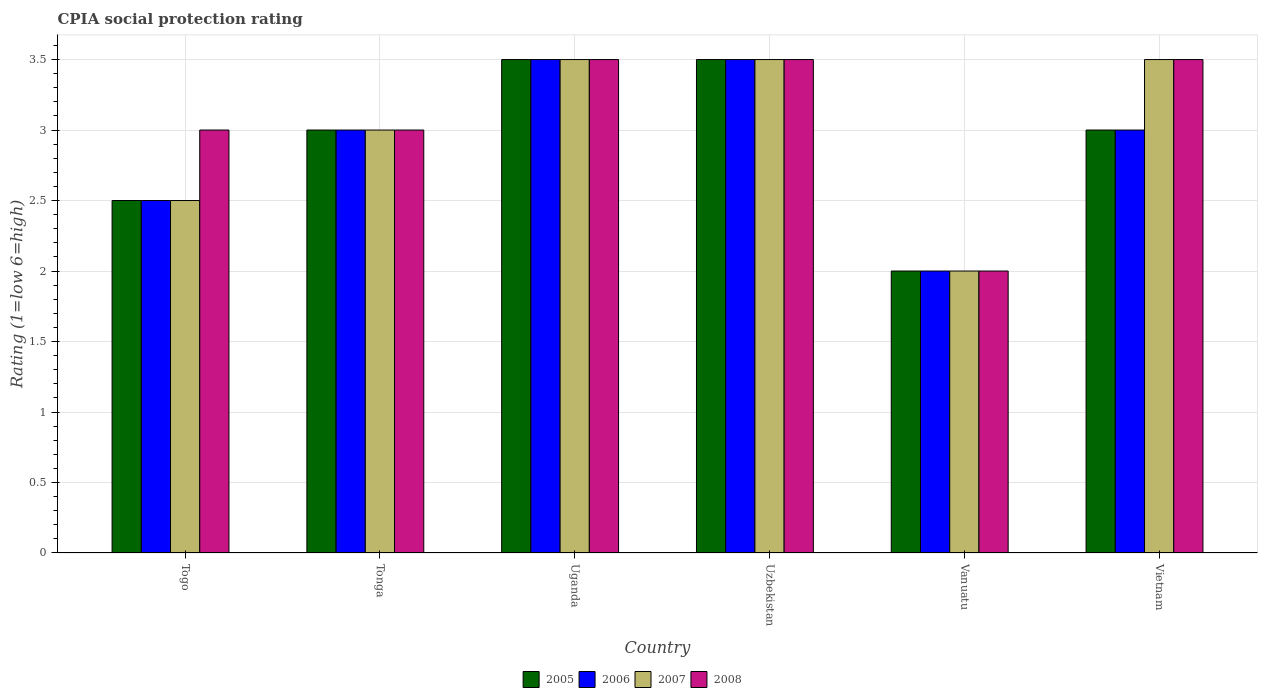How many different coloured bars are there?
Offer a terse response. 4. How many groups of bars are there?
Offer a terse response. 6. Are the number of bars on each tick of the X-axis equal?
Provide a succinct answer. Yes. How many bars are there on the 3rd tick from the left?
Make the answer very short. 4. What is the label of the 6th group of bars from the left?
Offer a terse response. Vietnam. In how many cases, is the number of bars for a given country not equal to the number of legend labels?
Give a very brief answer. 0. What is the CPIA rating in 2008 in Tonga?
Ensure brevity in your answer.  3. In which country was the CPIA rating in 2008 maximum?
Your answer should be compact. Uganda. In which country was the CPIA rating in 2006 minimum?
Provide a succinct answer. Vanuatu. What is the difference between the CPIA rating in 2008 in Togo and that in Vietnam?
Ensure brevity in your answer.  -0.5. What is the average CPIA rating in 2008 per country?
Your answer should be very brief. 3.08. What is the difference between the CPIA rating of/in 2005 and CPIA rating of/in 2008 in Togo?
Your response must be concise. -0.5. What is the ratio of the CPIA rating in 2007 in Tonga to that in Vietnam?
Give a very brief answer. 0.86. Is the CPIA rating in 2008 in Togo less than that in Uzbekistan?
Provide a succinct answer. Yes. What does the 2nd bar from the right in Vietnam represents?
Provide a succinct answer. 2007. Is it the case that in every country, the sum of the CPIA rating in 2005 and CPIA rating in 2006 is greater than the CPIA rating in 2008?
Your response must be concise. Yes. How many bars are there?
Ensure brevity in your answer.  24. What is the difference between two consecutive major ticks on the Y-axis?
Keep it short and to the point. 0.5. Does the graph contain any zero values?
Offer a very short reply. No. Does the graph contain grids?
Offer a terse response. Yes. Where does the legend appear in the graph?
Provide a succinct answer. Bottom center. What is the title of the graph?
Ensure brevity in your answer.  CPIA social protection rating. What is the Rating (1=low 6=high) in 2006 in Togo?
Your answer should be very brief. 2.5. What is the Rating (1=low 6=high) of 2008 in Togo?
Offer a very short reply. 3. What is the Rating (1=low 6=high) of 2006 in Tonga?
Provide a succinct answer. 3. What is the Rating (1=low 6=high) in 2007 in Tonga?
Offer a very short reply. 3. What is the Rating (1=low 6=high) of 2008 in Tonga?
Your answer should be very brief. 3. What is the Rating (1=low 6=high) in 2005 in Uganda?
Your response must be concise. 3.5. What is the Rating (1=low 6=high) of 2006 in Uganda?
Give a very brief answer. 3.5. What is the Rating (1=low 6=high) of 2007 in Uganda?
Offer a very short reply. 3.5. What is the Rating (1=low 6=high) in 2007 in Uzbekistan?
Your response must be concise. 3.5. What is the Rating (1=low 6=high) in 2008 in Uzbekistan?
Offer a terse response. 3.5. What is the Rating (1=low 6=high) in 2005 in Vanuatu?
Make the answer very short. 2. What is the Rating (1=low 6=high) in 2007 in Vanuatu?
Your answer should be very brief. 2. What is the Rating (1=low 6=high) in 2008 in Vanuatu?
Offer a terse response. 2. What is the Rating (1=low 6=high) in 2006 in Vietnam?
Offer a terse response. 3. Across all countries, what is the maximum Rating (1=low 6=high) in 2005?
Your response must be concise. 3.5. Across all countries, what is the minimum Rating (1=low 6=high) of 2005?
Make the answer very short. 2. Across all countries, what is the minimum Rating (1=low 6=high) of 2006?
Offer a very short reply. 2. Across all countries, what is the minimum Rating (1=low 6=high) of 2007?
Keep it short and to the point. 2. What is the difference between the Rating (1=low 6=high) of 2005 in Togo and that in Tonga?
Provide a short and direct response. -0.5. What is the difference between the Rating (1=low 6=high) in 2006 in Togo and that in Tonga?
Make the answer very short. -0.5. What is the difference between the Rating (1=low 6=high) of 2007 in Togo and that in Tonga?
Offer a terse response. -0.5. What is the difference between the Rating (1=low 6=high) in 2006 in Togo and that in Uganda?
Your answer should be compact. -1. What is the difference between the Rating (1=low 6=high) in 2007 in Togo and that in Uganda?
Your response must be concise. -1. What is the difference between the Rating (1=low 6=high) of 2008 in Togo and that in Uganda?
Your response must be concise. -0.5. What is the difference between the Rating (1=low 6=high) in 2005 in Togo and that in Uzbekistan?
Provide a succinct answer. -1. What is the difference between the Rating (1=low 6=high) of 2006 in Togo and that in Uzbekistan?
Offer a terse response. -1. What is the difference between the Rating (1=low 6=high) of 2007 in Togo and that in Uzbekistan?
Offer a very short reply. -1. What is the difference between the Rating (1=low 6=high) in 2005 in Togo and that in Vanuatu?
Offer a terse response. 0.5. What is the difference between the Rating (1=low 6=high) in 2007 in Togo and that in Vanuatu?
Your response must be concise. 0.5. What is the difference between the Rating (1=low 6=high) of 2006 in Togo and that in Vietnam?
Give a very brief answer. -0.5. What is the difference between the Rating (1=low 6=high) of 2007 in Togo and that in Vietnam?
Offer a terse response. -1. What is the difference between the Rating (1=low 6=high) in 2006 in Tonga and that in Uganda?
Offer a very short reply. -0.5. What is the difference between the Rating (1=low 6=high) of 2007 in Tonga and that in Uganda?
Give a very brief answer. -0.5. What is the difference between the Rating (1=low 6=high) of 2005 in Tonga and that in Uzbekistan?
Your answer should be compact. -0.5. What is the difference between the Rating (1=low 6=high) of 2008 in Tonga and that in Uzbekistan?
Keep it short and to the point. -0.5. What is the difference between the Rating (1=low 6=high) of 2008 in Tonga and that in Vanuatu?
Keep it short and to the point. 1. What is the difference between the Rating (1=low 6=high) in 2005 in Tonga and that in Vietnam?
Offer a terse response. 0. What is the difference between the Rating (1=low 6=high) in 2006 in Tonga and that in Vietnam?
Keep it short and to the point. 0. What is the difference between the Rating (1=low 6=high) of 2007 in Uganda and that in Uzbekistan?
Provide a short and direct response. 0. What is the difference between the Rating (1=low 6=high) of 2008 in Uganda and that in Uzbekistan?
Your answer should be very brief. 0. What is the difference between the Rating (1=low 6=high) in 2005 in Uganda and that in Vanuatu?
Ensure brevity in your answer.  1.5. What is the difference between the Rating (1=low 6=high) in 2007 in Uganda and that in Vanuatu?
Provide a succinct answer. 1.5. What is the difference between the Rating (1=low 6=high) in 2008 in Uganda and that in Vanuatu?
Your response must be concise. 1.5. What is the difference between the Rating (1=low 6=high) of 2005 in Uganda and that in Vietnam?
Ensure brevity in your answer.  0.5. What is the difference between the Rating (1=low 6=high) of 2007 in Uganda and that in Vietnam?
Ensure brevity in your answer.  0. What is the difference between the Rating (1=low 6=high) in 2008 in Uganda and that in Vietnam?
Keep it short and to the point. 0. What is the difference between the Rating (1=low 6=high) in 2006 in Uzbekistan and that in Vanuatu?
Make the answer very short. 1.5. What is the difference between the Rating (1=low 6=high) of 2007 in Uzbekistan and that in Vanuatu?
Provide a succinct answer. 1.5. What is the difference between the Rating (1=low 6=high) in 2008 in Vanuatu and that in Vietnam?
Keep it short and to the point. -1.5. What is the difference between the Rating (1=low 6=high) of 2005 in Togo and the Rating (1=low 6=high) of 2006 in Tonga?
Your answer should be very brief. -0.5. What is the difference between the Rating (1=low 6=high) of 2005 in Togo and the Rating (1=low 6=high) of 2008 in Tonga?
Keep it short and to the point. -0.5. What is the difference between the Rating (1=low 6=high) in 2007 in Togo and the Rating (1=low 6=high) in 2008 in Tonga?
Offer a terse response. -0.5. What is the difference between the Rating (1=low 6=high) in 2005 in Togo and the Rating (1=low 6=high) in 2007 in Uganda?
Your response must be concise. -1. What is the difference between the Rating (1=low 6=high) of 2005 in Togo and the Rating (1=low 6=high) of 2008 in Uganda?
Make the answer very short. -1. What is the difference between the Rating (1=low 6=high) in 2006 in Togo and the Rating (1=low 6=high) in 2007 in Uganda?
Make the answer very short. -1. What is the difference between the Rating (1=low 6=high) in 2006 in Togo and the Rating (1=low 6=high) in 2008 in Uganda?
Your answer should be very brief. -1. What is the difference between the Rating (1=low 6=high) of 2007 in Togo and the Rating (1=low 6=high) of 2008 in Uganda?
Provide a short and direct response. -1. What is the difference between the Rating (1=low 6=high) of 2005 in Togo and the Rating (1=low 6=high) of 2007 in Uzbekistan?
Keep it short and to the point. -1. What is the difference between the Rating (1=low 6=high) of 2006 in Togo and the Rating (1=low 6=high) of 2007 in Uzbekistan?
Give a very brief answer. -1. What is the difference between the Rating (1=low 6=high) of 2006 in Togo and the Rating (1=low 6=high) of 2008 in Vanuatu?
Ensure brevity in your answer.  0.5. What is the difference between the Rating (1=low 6=high) of 2007 in Togo and the Rating (1=low 6=high) of 2008 in Vanuatu?
Keep it short and to the point. 0.5. What is the difference between the Rating (1=low 6=high) in 2005 in Togo and the Rating (1=low 6=high) in 2006 in Vietnam?
Offer a very short reply. -0.5. What is the difference between the Rating (1=low 6=high) in 2005 in Togo and the Rating (1=low 6=high) in 2007 in Vietnam?
Ensure brevity in your answer.  -1. What is the difference between the Rating (1=low 6=high) in 2005 in Togo and the Rating (1=low 6=high) in 2008 in Vietnam?
Make the answer very short. -1. What is the difference between the Rating (1=low 6=high) of 2006 in Togo and the Rating (1=low 6=high) of 2007 in Vietnam?
Give a very brief answer. -1. What is the difference between the Rating (1=low 6=high) in 2006 in Tonga and the Rating (1=low 6=high) in 2007 in Uganda?
Your response must be concise. -0.5. What is the difference between the Rating (1=low 6=high) of 2006 in Tonga and the Rating (1=low 6=high) of 2008 in Uganda?
Ensure brevity in your answer.  -0.5. What is the difference between the Rating (1=low 6=high) of 2007 in Tonga and the Rating (1=low 6=high) of 2008 in Uganda?
Ensure brevity in your answer.  -0.5. What is the difference between the Rating (1=low 6=high) in 2005 in Tonga and the Rating (1=low 6=high) in 2006 in Uzbekistan?
Your response must be concise. -0.5. What is the difference between the Rating (1=low 6=high) in 2005 in Tonga and the Rating (1=low 6=high) in 2007 in Uzbekistan?
Keep it short and to the point. -0.5. What is the difference between the Rating (1=low 6=high) of 2005 in Tonga and the Rating (1=low 6=high) of 2008 in Vanuatu?
Make the answer very short. 1. What is the difference between the Rating (1=low 6=high) of 2006 in Tonga and the Rating (1=low 6=high) of 2008 in Vanuatu?
Your answer should be very brief. 1. What is the difference between the Rating (1=low 6=high) in 2007 in Tonga and the Rating (1=low 6=high) in 2008 in Vanuatu?
Keep it short and to the point. 1. What is the difference between the Rating (1=low 6=high) in 2005 in Tonga and the Rating (1=low 6=high) in 2006 in Vietnam?
Provide a succinct answer. 0. What is the difference between the Rating (1=low 6=high) in 2005 in Tonga and the Rating (1=low 6=high) in 2007 in Vietnam?
Offer a terse response. -0.5. What is the difference between the Rating (1=low 6=high) of 2006 in Tonga and the Rating (1=low 6=high) of 2008 in Vietnam?
Make the answer very short. -0.5. What is the difference between the Rating (1=low 6=high) of 2005 in Uganda and the Rating (1=low 6=high) of 2006 in Uzbekistan?
Give a very brief answer. 0. What is the difference between the Rating (1=low 6=high) of 2006 in Uganda and the Rating (1=low 6=high) of 2007 in Uzbekistan?
Offer a terse response. 0. What is the difference between the Rating (1=low 6=high) in 2006 in Uganda and the Rating (1=low 6=high) in 2008 in Uzbekistan?
Ensure brevity in your answer.  0. What is the difference between the Rating (1=low 6=high) in 2005 in Uganda and the Rating (1=low 6=high) in 2006 in Vanuatu?
Your answer should be compact. 1.5. What is the difference between the Rating (1=low 6=high) of 2005 in Uganda and the Rating (1=low 6=high) of 2008 in Vanuatu?
Your response must be concise. 1.5. What is the difference between the Rating (1=low 6=high) of 2006 in Uganda and the Rating (1=low 6=high) of 2008 in Vanuatu?
Your answer should be very brief. 1.5. What is the difference between the Rating (1=low 6=high) of 2005 in Uganda and the Rating (1=low 6=high) of 2006 in Vietnam?
Your response must be concise. 0.5. What is the difference between the Rating (1=low 6=high) in 2005 in Uganda and the Rating (1=low 6=high) in 2007 in Vietnam?
Provide a short and direct response. 0. What is the difference between the Rating (1=low 6=high) in 2005 in Uganda and the Rating (1=low 6=high) in 2008 in Vietnam?
Provide a succinct answer. 0. What is the difference between the Rating (1=low 6=high) in 2006 in Uganda and the Rating (1=low 6=high) in 2007 in Vietnam?
Offer a very short reply. 0. What is the difference between the Rating (1=low 6=high) in 2006 in Uganda and the Rating (1=low 6=high) in 2008 in Vietnam?
Keep it short and to the point. 0. What is the difference between the Rating (1=low 6=high) of 2007 in Uganda and the Rating (1=low 6=high) of 2008 in Vietnam?
Provide a succinct answer. 0. What is the difference between the Rating (1=low 6=high) of 2005 in Uzbekistan and the Rating (1=low 6=high) of 2006 in Vanuatu?
Give a very brief answer. 1.5. What is the difference between the Rating (1=low 6=high) in 2006 in Uzbekistan and the Rating (1=low 6=high) in 2007 in Vanuatu?
Offer a terse response. 1.5. What is the difference between the Rating (1=low 6=high) of 2005 in Uzbekistan and the Rating (1=low 6=high) of 2006 in Vietnam?
Give a very brief answer. 0.5. What is the difference between the Rating (1=low 6=high) in 2006 in Uzbekistan and the Rating (1=low 6=high) in 2008 in Vietnam?
Your answer should be compact. 0. What is the difference between the Rating (1=low 6=high) of 2005 in Vanuatu and the Rating (1=low 6=high) of 2006 in Vietnam?
Give a very brief answer. -1. What is the average Rating (1=low 6=high) of 2005 per country?
Keep it short and to the point. 2.92. What is the average Rating (1=low 6=high) in 2006 per country?
Keep it short and to the point. 2.92. What is the average Rating (1=low 6=high) of 2008 per country?
Give a very brief answer. 3.08. What is the difference between the Rating (1=low 6=high) in 2005 and Rating (1=low 6=high) in 2006 in Togo?
Provide a short and direct response. 0. What is the difference between the Rating (1=low 6=high) of 2005 and Rating (1=low 6=high) of 2007 in Togo?
Keep it short and to the point. 0. What is the difference between the Rating (1=low 6=high) of 2006 and Rating (1=low 6=high) of 2007 in Togo?
Your answer should be very brief. 0. What is the difference between the Rating (1=low 6=high) in 2005 and Rating (1=low 6=high) in 2008 in Tonga?
Your response must be concise. 0. What is the difference between the Rating (1=low 6=high) of 2006 and Rating (1=low 6=high) of 2007 in Tonga?
Make the answer very short. 0. What is the difference between the Rating (1=low 6=high) in 2007 and Rating (1=low 6=high) in 2008 in Tonga?
Keep it short and to the point. 0. What is the difference between the Rating (1=low 6=high) in 2005 and Rating (1=low 6=high) in 2006 in Uganda?
Your answer should be very brief. 0. What is the difference between the Rating (1=low 6=high) in 2005 and Rating (1=low 6=high) in 2007 in Uganda?
Your answer should be very brief. 0. What is the difference between the Rating (1=low 6=high) in 2006 and Rating (1=low 6=high) in 2007 in Uganda?
Ensure brevity in your answer.  0. What is the difference between the Rating (1=low 6=high) in 2006 and Rating (1=low 6=high) in 2008 in Uganda?
Ensure brevity in your answer.  0. What is the difference between the Rating (1=low 6=high) in 2007 and Rating (1=low 6=high) in 2008 in Uganda?
Your answer should be compact. 0. What is the difference between the Rating (1=low 6=high) of 2005 and Rating (1=low 6=high) of 2006 in Uzbekistan?
Your response must be concise. 0. What is the difference between the Rating (1=low 6=high) in 2005 and Rating (1=low 6=high) in 2008 in Uzbekistan?
Ensure brevity in your answer.  0. What is the difference between the Rating (1=low 6=high) in 2006 and Rating (1=low 6=high) in 2007 in Uzbekistan?
Ensure brevity in your answer.  0. What is the difference between the Rating (1=low 6=high) of 2006 and Rating (1=low 6=high) of 2008 in Uzbekistan?
Keep it short and to the point. 0. What is the difference between the Rating (1=low 6=high) in 2007 and Rating (1=low 6=high) in 2008 in Uzbekistan?
Your response must be concise. 0. What is the difference between the Rating (1=low 6=high) in 2005 and Rating (1=low 6=high) in 2006 in Vanuatu?
Your answer should be compact. 0. What is the difference between the Rating (1=low 6=high) in 2005 and Rating (1=low 6=high) in 2008 in Vanuatu?
Your answer should be compact. 0. What is the difference between the Rating (1=low 6=high) of 2006 and Rating (1=low 6=high) of 2007 in Vanuatu?
Give a very brief answer. 0. What is the difference between the Rating (1=low 6=high) of 2007 and Rating (1=low 6=high) of 2008 in Vanuatu?
Keep it short and to the point. 0. What is the difference between the Rating (1=low 6=high) of 2005 and Rating (1=low 6=high) of 2008 in Vietnam?
Your response must be concise. -0.5. What is the difference between the Rating (1=low 6=high) of 2006 and Rating (1=low 6=high) of 2007 in Vietnam?
Make the answer very short. -0.5. What is the ratio of the Rating (1=low 6=high) of 2005 in Togo to that in Tonga?
Offer a very short reply. 0.83. What is the ratio of the Rating (1=low 6=high) of 2006 in Togo to that in Tonga?
Keep it short and to the point. 0.83. What is the ratio of the Rating (1=low 6=high) in 2007 in Togo to that in Tonga?
Provide a short and direct response. 0.83. What is the ratio of the Rating (1=low 6=high) in 2008 in Togo to that in Tonga?
Give a very brief answer. 1. What is the ratio of the Rating (1=low 6=high) in 2005 in Togo to that in Uganda?
Offer a very short reply. 0.71. What is the ratio of the Rating (1=low 6=high) in 2008 in Togo to that in Uganda?
Provide a short and direct response. 0.86. What is the ratio of the Rating (1=low 6=high) of 2005 in Togo to that in Uzbekistan?
Give a very brief answer. 0.71. What is the ratio of the Rating (1=low 6=high) of 2006 in Togo to that in Uzbekistan?
Your answer should be very brief. 0.71. What is the ratio of the Rating (1=low 6=high) in 2005 in Togo to that in Vanuatu?
Keep it short and to the point. 1.25. What is the ratio of the Rating (1=low 6=high) in 2008 in Togo to that in Vanuatu?
Ensure brevity in your answer.  1.5. What is the ratio of the Rating (1=low 6=high) in 2005 in Togo to that in Vietnam?
Ensure brevity in your answer.  0.83. What is the ratio of the Rating (1=low 6=high) in 2007 in Togo to that in Vietnam?
Provide a short and direct response. 0.71. What is the ratio of the Rating (1=low 6=high) in 2008 in Togo to that in Vietnam?
Keep it short and to the point. 0.86. What is the ratio of the Rating (1=low 6=high) of 2006 in Tonga to that in Uganda?
Provide a succinct answer. 0.86. What is the ratio of the Rating (1=low 6=high) of 2005 in Tonga to that in Uzbekistan?
Your answer should be compact. 0.86. What is the ratio of the Rating (1=low 6=high) in 2008 in Tonga to that in Uzbekistan?
Give a very brief answer. 0.86. What is the ratio of the Rating (1=low 6=high) of 2005 in Tonga to that in Vanuatu?
Your response must be concise. 1.5. What is the ratio of the Rating (1=low 6=high) of 2007 in Tonga to that in Vanuatu?
Offer a terse response. 1.5. What is the ratio of the Rating (1=low 6=high) of 2005 in Tonga to that in Vietnam?
Offer a terse response. 1. What is the ratio of the Rating (1=low 6=high) in 2006 in Tonga to that in Vietnam?
Provide a short and direct response. 1. What is the ratio of the Rating (1=low 6=high) in 2007 in Tonga to that in Vietnam?
Your response must be concise. 0.86. What is the ratio of the Rating (1=low 6=high) of 2008 in Tonga to that in Vietnam?
Ensure brevity in your answer.  0.86. What is the ratio of the Rating (1=low 6=high) of 2005 in Uganda to that in Uzbekistan?
Ensure brevity in your answer.  1. What is the ratio of the Rating (1=low 6=high) in 2006 in Uganda to that in Uzbekistan?
Give a very brief answer. 1. What is the ratio of the Rating (1=low 6=high) in 2007 in Uganda to that in Uzbekistan?
Keep it short and to the point. 1. What is the ratio of the Rating (1=low 6=high) of 2006 in Uganda to that in Vanuatu?
Your answer should be compact. 1.75. What is the ratio of the Rating (1=low 6=high) of 2008 in Uganda to that in Vanuatu?
Provide a succinct answer. 1.75. What is the ratio of the Rating (1=low 6=high) in 2005 in Uganda to that in Vietnam?
Your response must be concise. 1.17. What is the ratio of the Rating (1=low 6=high) of 2006 in Uganda to that in Vietnam?
Ensure brevity in your answer.  1.17. What is the ratio of the Rating (1=low 6=high) of 2007 in Uganda to that in Vietnam?
Your answer should be very brief. 1. What is the ratio of the Rating (1=low 6=high) in 2008 in Uganda to that in Vietnam?
Provide a short and direct response. 1. What is the ratio of the Rating (1=low 6=high) in 2006 in Uzbekistan to that in Vanuatu?
Provide a short and direct response. 1.75. What is the ratio of the Rating (1=low 6=high) of 2008 in Uzbekistan to that in Vanuatu?
Offer a terse response. 1.75. What is the ratio of the Rating (1=low 6=high) in 2007 in Uzbekistan to that in Vietnam?
Your response must be concise. 1. What is the ratio of the Rating (1=low 6=high) in 2007 in Vanuatu to that in Vietnam?
Your answer should be very brief. 0.57. What is the difference between the highest and the second highest Rating (1=low 6=high) in 2005?
Provide a short and direct response. 0. What is the difference between the highest and the second highest Rating (1=low 6=high) in 2006?
Ensure brevity in your answer.  0. What is the difference between the highest and the second highest Rating (1=low 6=high) of 2007?
Ensure brevity in your answer.  0. What is the difference between the highest and the second highest Rating (1=low 6=high) in 2008?
Your answer should be compact. 0. What is the difference between the highest and the lowest Rating (1=low 6=high) of 2008?
Your response must be concise. 1.5. 